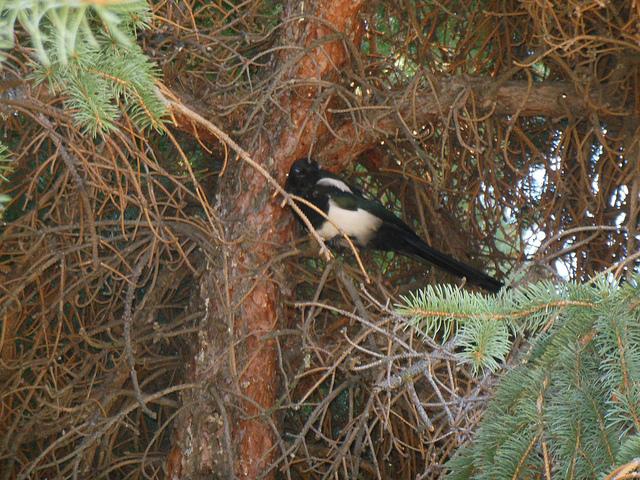Where is the bird?
Quick response, please. In tree. What colors does the bird consist of?
Keep it brief. Black and white. What color is the bird?
Be succinct. Black and white. What type of tree is this?
Answer briefly. Pine. 